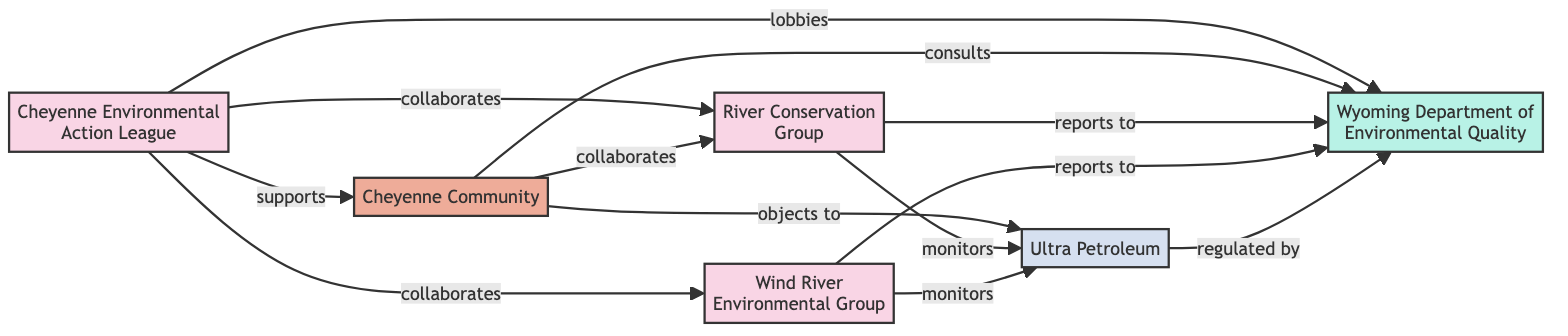What is the total number of entities in the diagram? The diagram lists six entities, including organizations, a community, a corporation, and a government agency. By counting all unique entities, we arrive at a total of six.
Answer: 6 Which organization supports the Cheyenne Community? The relationship depicted shows that the Cheyenne Environmental Action League has a supporting relationship with the Cheyenne Community. This can be found by examining the directed edge leading from the Cheyenne Environmental Action League to the Cheyenne Community labeled "supports."
Answer: Cheyenne Environmental Action League How many organizations collaborate with the Cheyenne Environmental Action League? The Cheyenne Environmental Action League collaborates with two organizations: the River Conservation Group and the Wind River Environmental Group. This is determined by tracking the edges that originate from the Cheyenne Environmental Action League towards these two specific organizations.
Answer: 2 What type of relationship exists between the Cheyenne Community and Ultra Petroleum? According to the diagram, the relationship is labeled "objects to," indicating a disapproving stance from the Cheyenne Community towards Ultra Petroleum. This information is visible in the directed edge connecting these two entities.
Answer: objects to Which organization is monitored by both the River Conservation Group and Wind River Environmental Group? Both the River Conservation Group and Wind River Environmental Group monitor Ultra Petroleum, as evidenced by the edges that connect them to Ultra Petroleum and are labeled "monitors." This is confirmed by checking the relationships associated with these organizations.
Answer: Ultra Petroleum How many edges are connected to the Wyoming Department of Environmental Quality? There are four edges connected to the Wyoming Department of Environmental Quality, representing various reporting, consulting, and lobbying relationships with different entities. To confirm this, one would count the directed edges coming into and out of this node in the diagram.
Answer: 4 Which community consults the Wyoming Department of Environmental Quality? The Cheyenne Community is identified as the entity that consults the Wyoming Department of Environmental Quality, as indicated by the directed edge from the Cheyenne Community towards this government agency, labeled "consults."
Answer: Cheyenne Community What types of entities are present in the diagram? The diagram features four types of entities: organizations, a community, a corporation, and a government agency. This diversity is established by examining the categories that each entity falls into as indicated in the data.
Answer: organization, community, corporation, government agency Which organization lobbies the Wyoming Department of Environmental Quality? The Cheyenne Environmental Action League is the organization that lobbies the Wyoming Department of Environmental Quality, as illustrated by the directed edge connecting them and labeled "lobbies." This can be confirmed by following the path of relationships from the Cheyenne Environmental Action League to the government agency.
Answer: Cheyenne Environmental Action League 